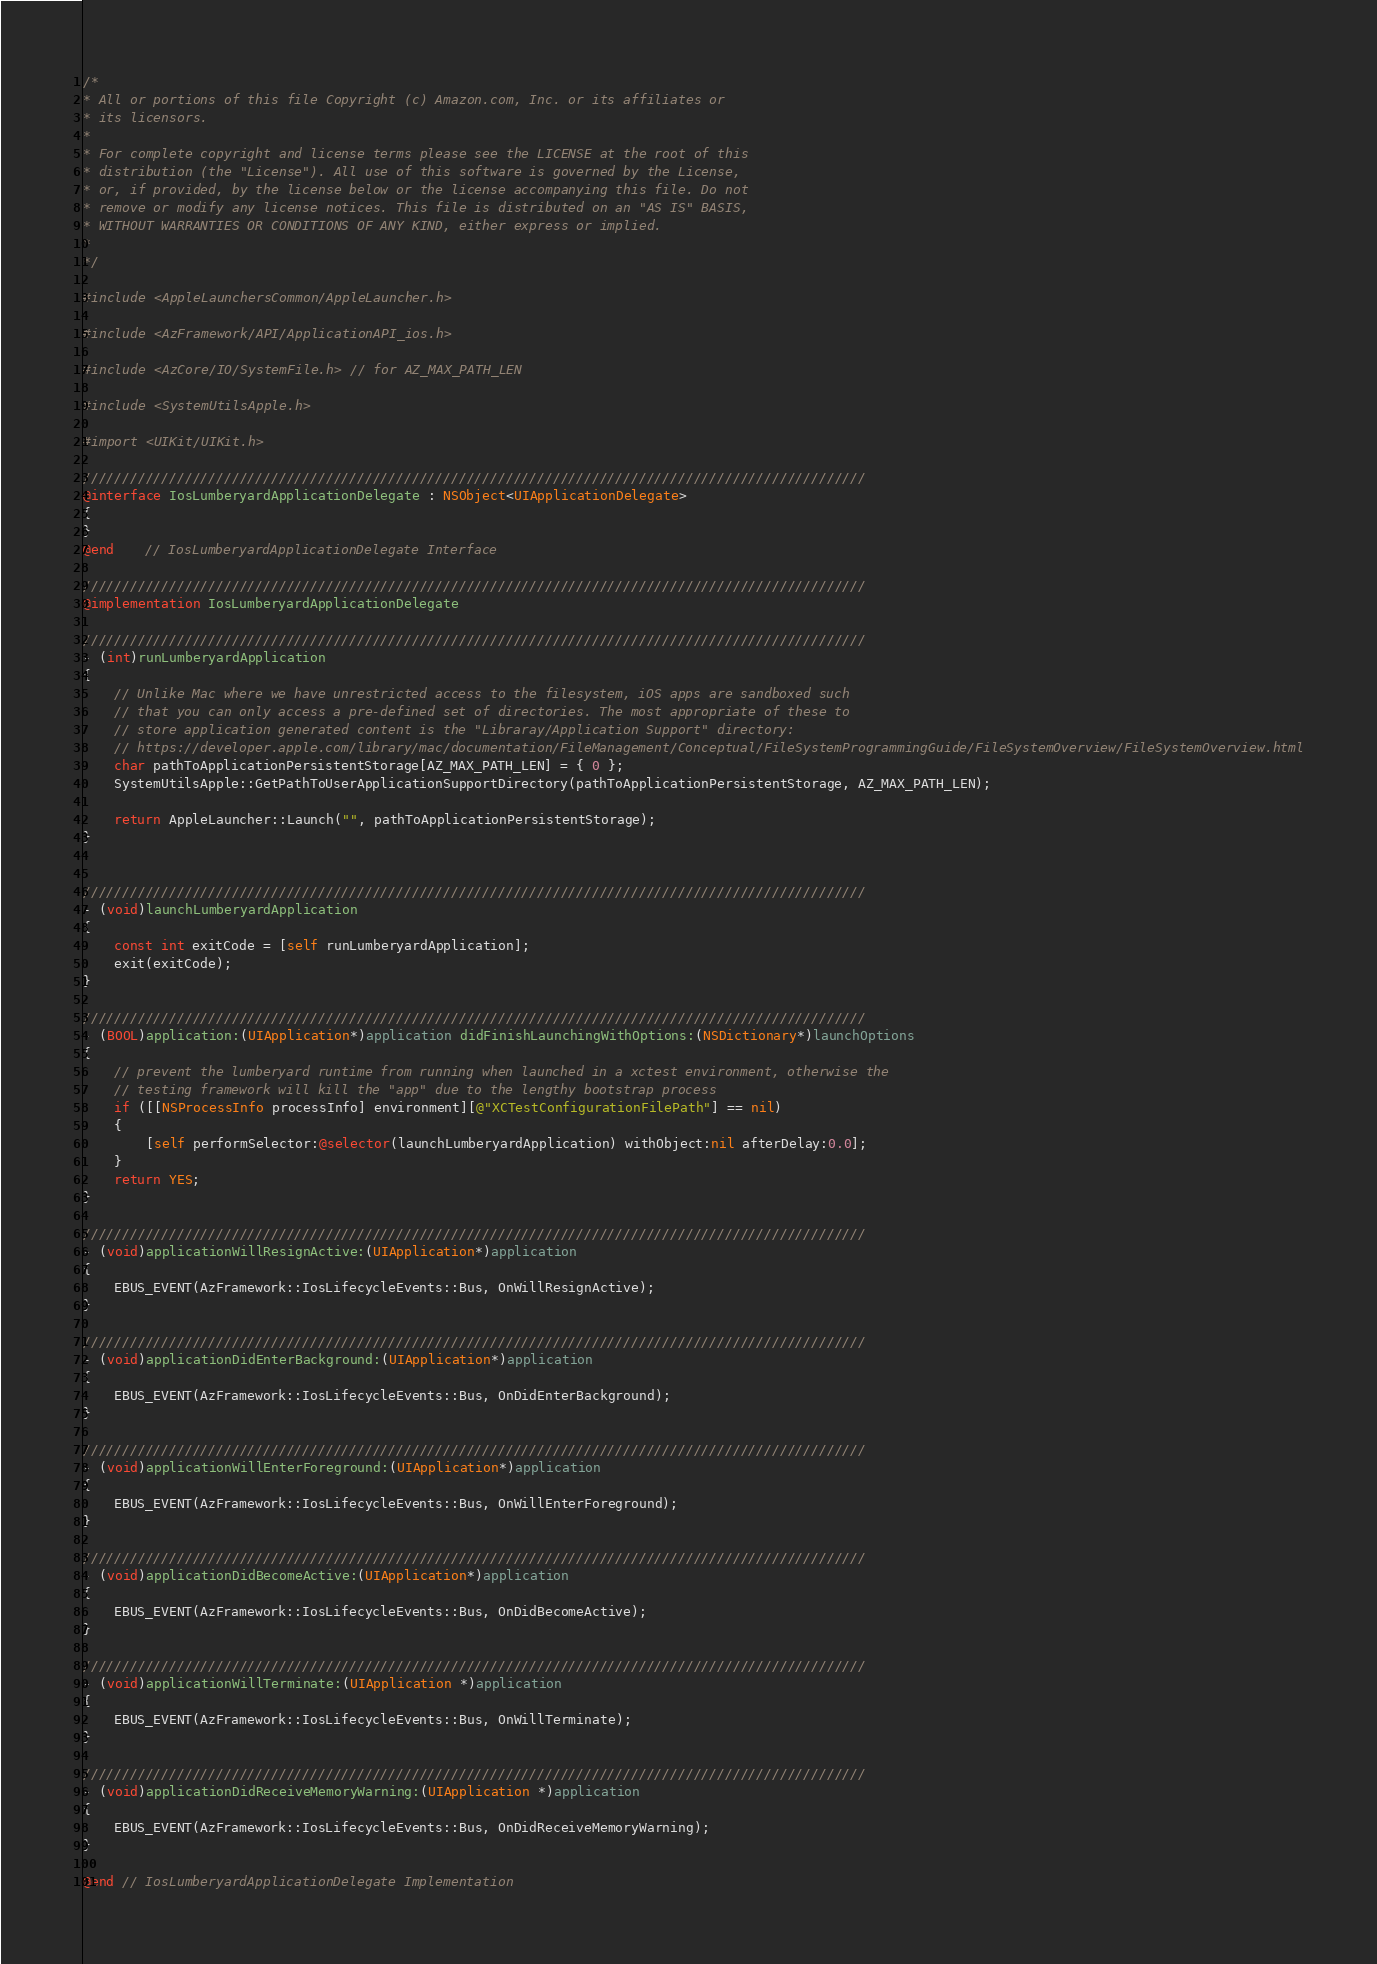Convert code to text. <code><loc_0><loc_0><loc_500><loc_500><_ObjectiveC_>/*
* All or portions of this file Copyright (c) Amazon.com, Inc. or its affiliates or
* its licensors.
*
* For complete copyright and license terms please see the LICENSE at the root of this
* distribution (the "License"). All use of this software is governed by the License,
* or, if provided, by the license below or the license accompanying this file. Do not
* remove or modify any license notices. This file is distributed on an "AS IS" BASIS,
* WITHOUT WARRANTIES OR CONDITIONS OF ANY KIND, either express or implied.
*
*/

#include <AppleLaunchersCommon/AppleLauncher.h>

#include <AzFramework/API/ApplicationAPI_ios.h>

#include <AzCore/IO/SystemFile.h> // for AZ_MAX_PATH_LEN

#include <SystemUtilsApple.h>

#import <UIKit/UIKit.h>

////////////////////////////////////////////////////////////////////////////////////////////////////
@interface IosLumberyardApplicationDelegate : NSObject<UIApplicationDelegate>
{
}
@end    // IosLumberyardApplicationDelegate Interface

////////////////////////////////////////////////////////////////////////////////////////////////////
@implementation IosLumberyardApplicationDelegate

////////////////////////////////////////////////////////////////////////////////////////////////////
- (int)runLumberyardApplication
{
    // Unlike Mac where we have unrestricted access to the filesystem, iOS apps are sandboxed such
    // that you can only access a pre-defined set of directories. The most appropriate of these to
    // store application generated content is the "Libraray/Application Support" directory:
    // https://developer.apple.com/library/mac/documentation/FileManagement/Conceptual/FileSystemProgrammingGuide/FileSystemOverview/FileSystemOverview.html
    char pathToApplicationPersistentStorage[AZ_MAX_PATH_LEN] = { 0 };
    SystemUtilsApple::GetPathToUserApplicationSupportDirectory(pathToApplicationPersistentStorage, AZ_MAX_PATH_LEN);

    return AppleLauncher::Launch("", pathToApplicationPersistentStorage);
}


////////////////////////////////////////////////////////////////////////////////////////////////////
- (void)launchLumberyardApplication
{
    const int exitCode = [self runLumberyardApplication];
    exit(exitCode);
}

////////////////////////////////////////////////////////////////////////////////////////////////////
- (BOOL)application:(UIApplication*)application didFinishLaunchingWithOptions:(NSDictionary*)launchOptions
{
    // prevent the lumberyard runtime from running when launched in a xctest environment, otherwise the
    // testing framework will kill the "app" due to the lengthy bootstrap process
    if ([[NSProcessInfo processInfo] environment][@"XCTestConfigurationFilePath"] == nil)
    {
        [self performSelector:@selector(launchLumberyardApplication) withObject:nil afterDelay:0.0];
    }
    return YES;
}

////////////////////////////////////////////////////////////////////////////////////////////////////
- (void)applicationWillResignActive:(UIApplication*)application
{
    EBUS_EVENT(AzFramework::IosLifecycleEvents::Bus, OnWillResignActive);
}

////////////////////////////////////////////////////////////////////////////////////////////////////
- (void)applicationDidEnterBackground:(UIApplication*)application
{
    EBUS_EVENT(AzFramework::IosLifecycleEvents::Bus, OnDidEnterBackground);
}

////////////////////////////////////////////////////////////////////////////////////////////////////
- (void)applicationWillEnterForeground:(UIApplication*)application
{
    EBUS_EVENT(AzFramework::IosLifecycleEvents::Bus, OnWillEnterForeground);
}

////////////////////////////////////////////////////////////////////////////////////////////////////
- (void)applicationDidBecomeActive:(UIApplication*)application
{
    EBUS_EVENT(AzFramework::IosLifecycleEvents::Bus, OnDidBecomeActive);
}

////////////////////////////////////////////////////////////////////////////////////////////////////
- (void)applicationWillTerminate:(UIApplication *)application
{
    EBUS_EVENT(AzFramework::IosLifecycleEvents::Bus, OnWillTerminate);
}

////////////////////////////////////////////////////////////////////////////////////////////////////
- (void)applicationDidReceiveMemoryWarning:(UIApplication *)application
{
    EBUS_EVENT(AzFramework::IosLifecycleEvents::Bus, OnDidReceiveMemoryWarning);
}

@end // IosLumberyardApplicationDelegate Implementation
</code> 